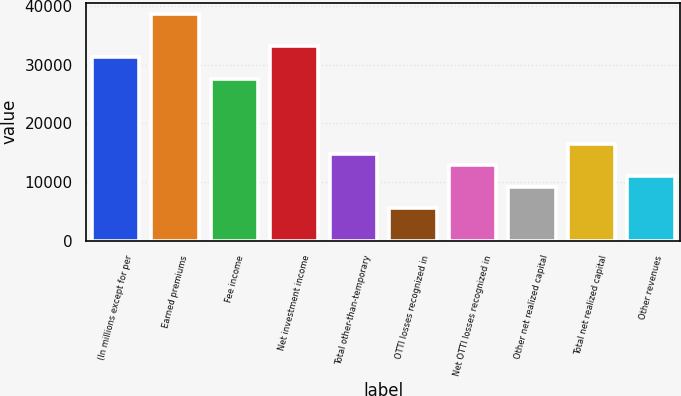Convert chart to OTSL. <chart><loc_0><loc_0><loc_500><loc_500><bar_chart><fcel>(In millions except for per<fcel>Earned premiums<fcel>Fee income<fcel>Net investment income<fcel>Total other-than-temporary<fcel>OTTI losses recognized in<fcel>Net OTTI losses recognized in<fcel>Other net realized capital<fcel>Total net realized capital<fcel>Other revenues<nl><fcel>31240.3<fcel>38590.8<fcel>27565.1<fcel>33077.9<fcel>14701.7<fcel>5513.64<fcel>12864.1<fcel>9188.88<fcel>16539.4<fcel>11026.5<nl></chart> 